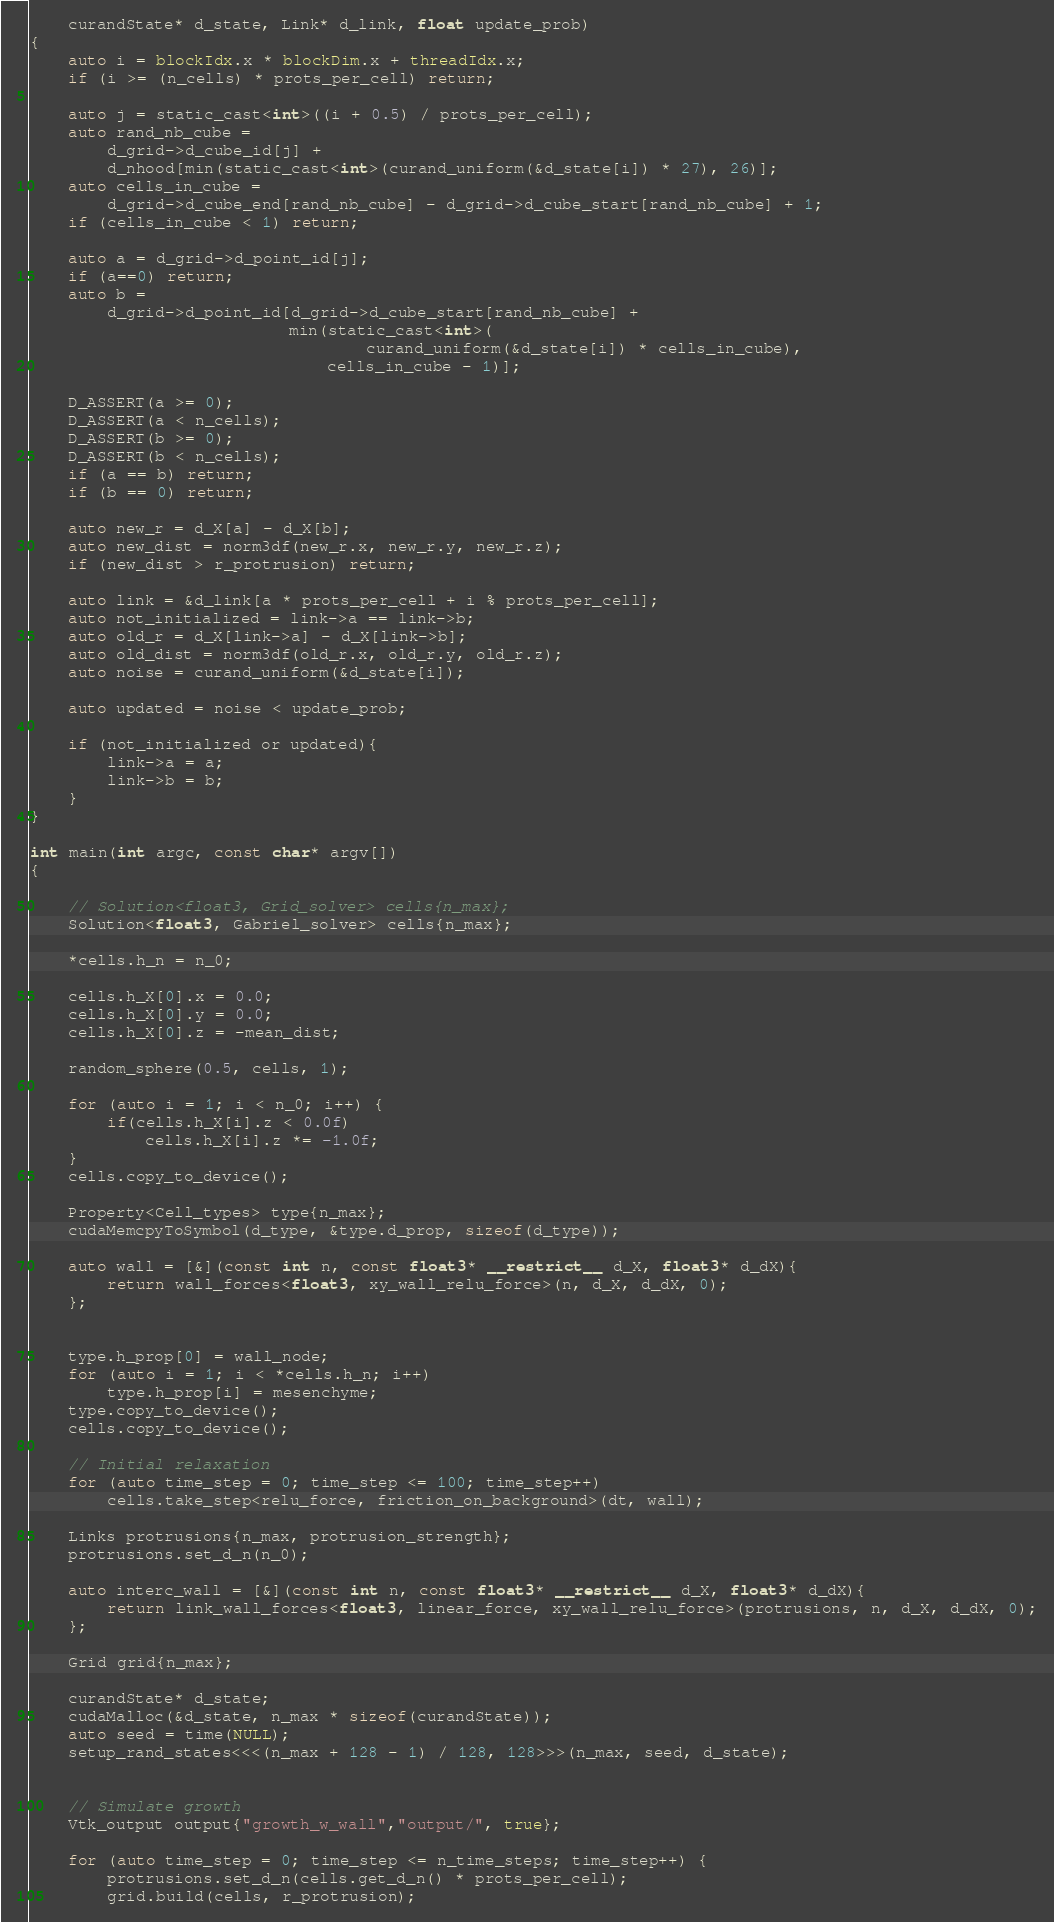<code> <loc_0><loc_0><loc_500><loc_500><_Cuda_>    curandState* d_state, Link* d_link, float update_prob)
{
    auto i = blockIdx.x * blockDim.x + threadIdx.x;
    if (i >= (n_cells) * prots_per_cell) return;

    auto j = static_cast<int>((i + 0.5) / prots_per_cell);
    auto rand_nb_cube =
        d_grid->d_cube_id[j] +
        d_nhood[min(static_cast<int>(curand_uniform(&d_state[i]) * 27), 26)];
    auto cells_in_cube =
        d_grid->d_cube_end[rand_nb_cube] - d_grid->d_cube_start[rand_nb_cube] + 1;
    if (cells_in_cube < 1) return;

    auto a = d_grid->d_point_id[j];
    if (a==0) return;
    auto b =
        d_grid->d_point_id[d_grid->d_cube_start[rand_nb_cube] +
                           min(static_cast<int>(
                                   curand_uniform(&d_state[i]) * cells_in_cube),
                               cells_in_cube - 1)];

    D_ASSERT(a >= 0);
    D_ASSERT(a < n_cells);
    D_ASSERT(b >= 0);
    D_ASSERT(b < n_cells);
    if (a == b) return;
    if (b == 0) return;

    auto new_r = d_X[a] - d_X[b];
    auto new_dist = norm3df(new_r.x, new_r.y, new_r.z);
    if (new_dist > r_protrusion) return;

    auto link = &d_link[a * prots_per_cell + i % prots_per_cell];
    auto not_initialized = link->a == link->b;
    auto old_r = d_X[link->a] - d_X[link->b];
    auto old_dist = norm3df(old_r.x, old_r.y, old_r.z);
    auto noise = curand_uniform(&d_state[i]);

    auto updated = noise < update_prob;

    if (not_initialized or updated){
        link->a = a;
        link->b = b;
    }
}

int main(int argc, const char* argv[])
{

    // Solution<float3, Grid_solver> cells{n_max};
    Solution<float3, Gabriel_solver> cells{n_max};

    *cells.h_n = n_0;

    cells.h_X[0].x = 0.0;
    cells.h_X[0].y = 0.0;
    cells.h_X[0].z = -mean_dist;

    random_sphere(0.5, cells, 1);

    for (auto i = 1; i < n_0; i++) {
        if(cells.h_X[i].z < 0.0f)
            cells.h_X[i].z *= -1.0f;
    }
    cells.copy_to_device();

    Property<Cell_types> type{n_max};
    cudaMemcpyToSymbol(d_type, &type.d_prop, sizeof(d_type));

    auto wall = [&](const int n, const float3* __restrict__ d_X, float3* d_dX){
        return wall_forces<float3, xy_wall_relu_force>(n, d_X, d_dX, 0);
    };


    type.h_prop[0] = wall_node;
    for (auto i = 1; i < *cells.h_n; i++)
        type.h_prop[i] = mesenchyme;
    type.copy_to_device();
    cells.copy_to_device();

    // Initial relaxation
    for (auto time_step = 0; time_step <= 100; time_step++)
        cells.take_step<relu_force, friction_on_background>(dt, wall);

    Links protrusions{n_max, protrusion_strength};
    protrusions.set_d_n(n_0);

    auto interc_wall = [&](const int n, const float3* __restrict__ d_X, float3* d_dX){
        return link_wall_forces<float3, linear_force, xy_wall_relu_force>(protrusions, n, d_X, d_dX, 0);
    };

    Grid grid{n_max};

    curandState* d_state;
    cudaMalloc(&d_state, n_max * sizeof(curandState));
    auto seed = time(NULL);
    setup_rand_states<<<(n_max + 128 - 1) / 128, 128>>>(n_max, seed, d_state);


    // Simulate growth
    Vtk_output output{"growth_w_wall","output/", true};

    for (auto time_step = 0; time_step <= n_time_steps; time_step++) {
        protrusions.set_d_n(cells.get_d_n() * prots_per_cell);
        grid.build(cells, r_protrusion);
</code> 